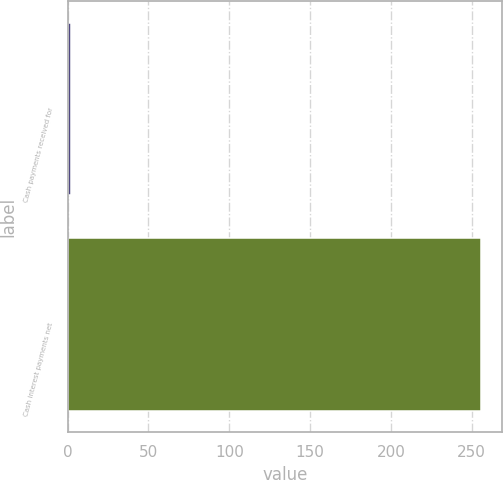<chart> <loc_0><loc_0><loc_500><loc_500><bar_chart><fcel>Cash payments received for<fcel>Cash interest payments net<nl><fcel>2<fcel>256<nl></chart> 